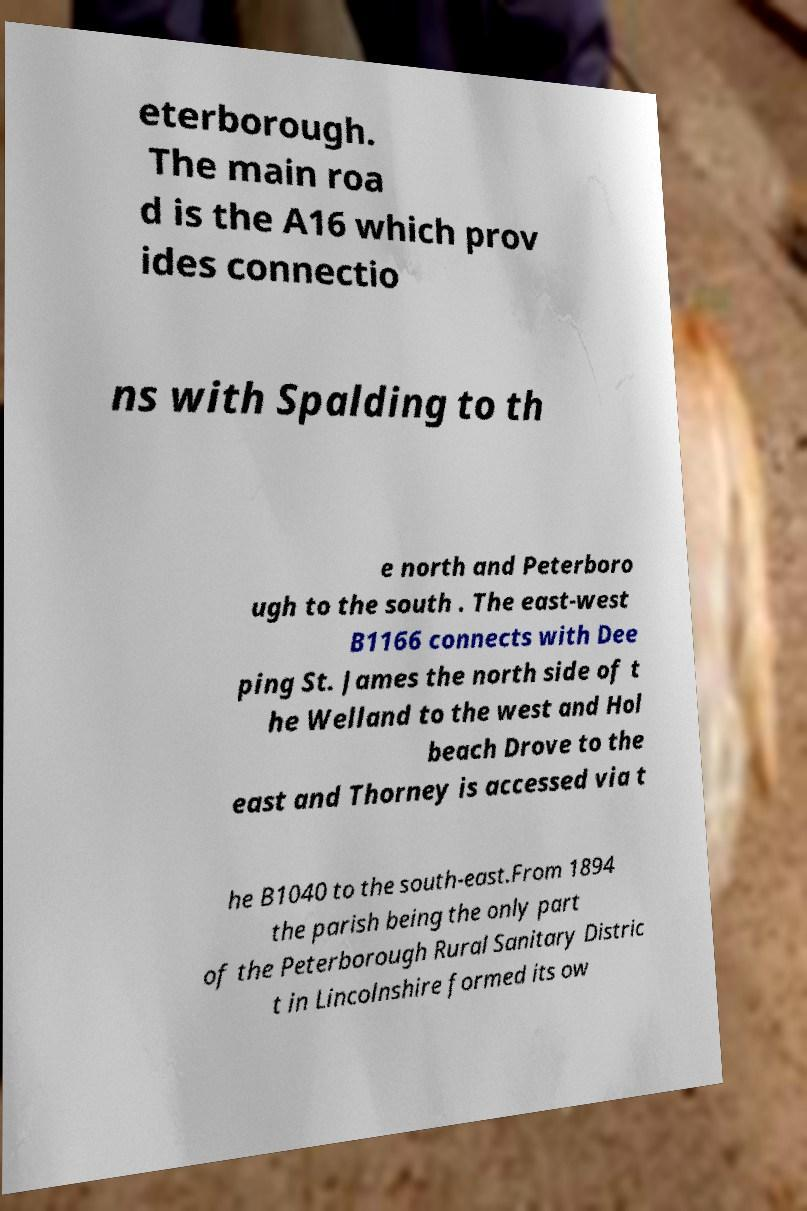I need the written content from this picture converted into text. Can you do that? eterborough. The main roa d is the A16 which prov ides connectio ns with Spalding to th e north and Peterboro ugh to the south . The east-west B1166 connects with Dee ping St. James the north side of t he Welland to the west and Hol beach Drove to the east and Thorney is accessed via t he B1040 to the south-east.From 1894 the parish being the only part of the Peterborough Rural Sanitary Distric t in Lincolnshire formed its ow 